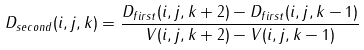Convert formula to latex. <formula><loc_0><loc_0><loc_500><loc_500>D _ { s e c o n d } ( i , j , k ) = \frac { D _ { f i r s t } ( i , j , k + 2 ) - D _ { f i r s t } ( i , j , k - 1 ) } { V ( i , j , k + 2 ) - V ( i , j , k - 1 ) }</formula> 